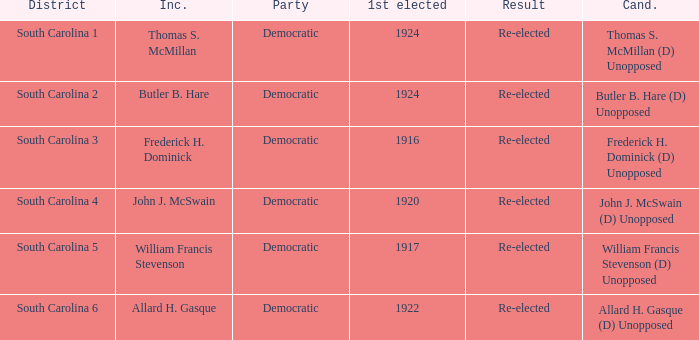What is the party for south carolina 3? Democratic. 